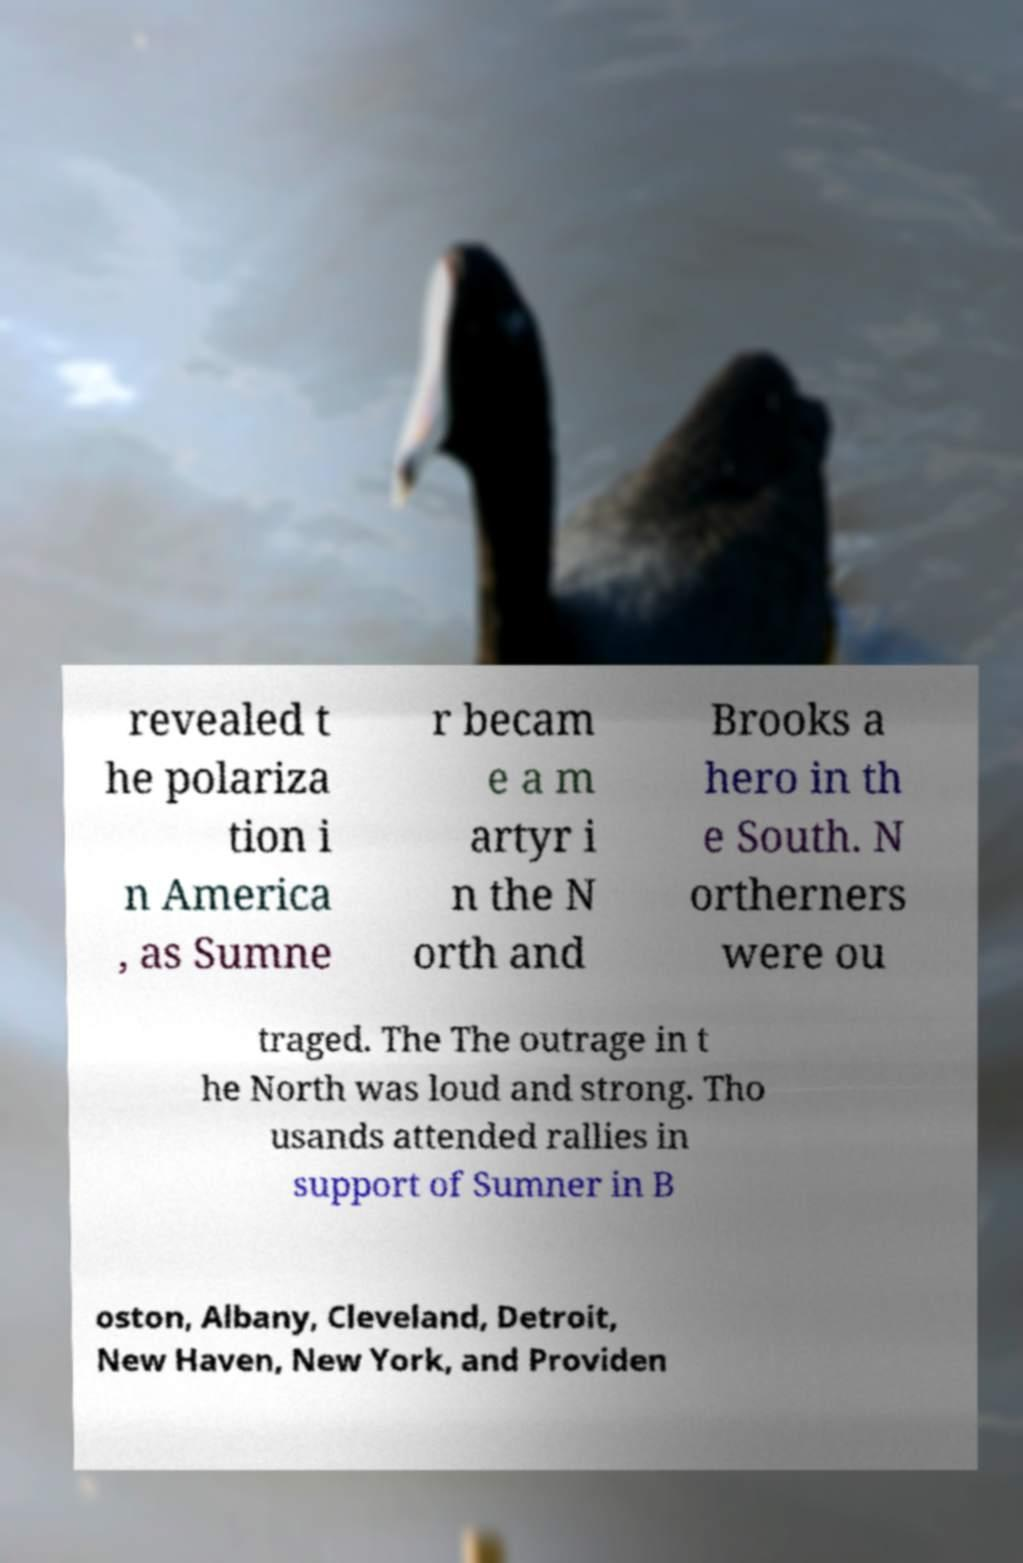Can you read and provide the text displayed in the image?This photo seems to have some interesting text. Can you extract and type it out for me? revealed t he polariza tion i n America , as Sumne r becam e a m artyr i n the N orth and Brooks a hero in th e South. N ortherners were ou traged. The The outrage in t he North was loud and strong. Tho usands attended rallies in support of Sumner in B oston, Albany, Cleveland, Detroit, New Haven, New York, and Providen 